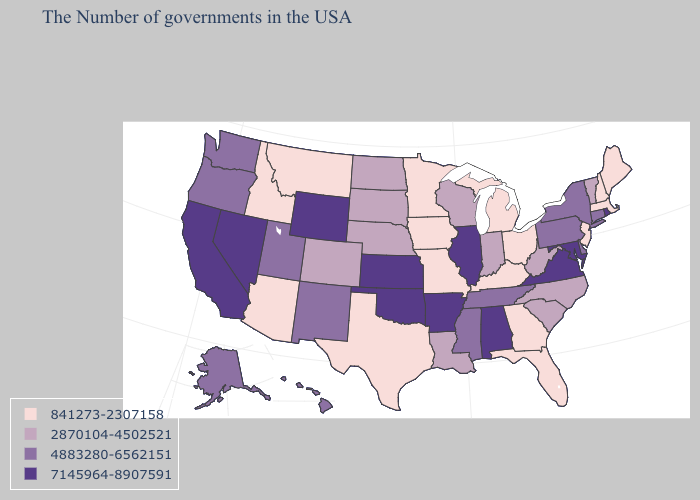Does South Dakota have a higher value than Wisconsin?
Keep it brief. No. Name the states that have a value in the range 7145964-8907591?
Give a very brief answer. Rhode Island, Maryland, Virginia, Alabama, Illinois, Arkansas, Kansas, Oklahoma, Wyoming, Nevada, California. What is the highest value in the West ?
Quick response, please. 7145964-8907591. Which states have the lowest value in the USA?
Short answer required. Maine, Massachusetts, New Hampshire, New Jersey, Ohio, Florida, Georgia, Michigan, Kentucky, Missouri, Minnesota, Iowa, Texas, Montana, Arizona, Idaho. Name the states that have a value in the range 4883280-6562151?
Keep it brief. Connecticut, New York, Delaware, Pennsylvania, Tennessee, Mississippi, New Mexico, Utah, Washington, Oregon, Alaska, Hawaii. What is the value of North Dakota?
Quick response, please. 2870104-4502521. What is the lowest value in the MidWest?
Be succinct. 841273-2307158. Name the states that have a value in the range 2870104-4502521?
Answer briefly. Vermont, North Carolina, South Carolina, West Virginia, Indiana, Wisconsin, Louisiana, Nebraska, South Dakota, North Dakota, Colorado. Name the states that have a value in the range 7145964-8907591?
Short answer required. Rhode Island, Maryland, Virginia, Alabama, Illinois, Arkansas, Kansas, Oklahoma, Wyoming, Nevada, California. Among the states that border Missouri , does Nebraska have the highest value?
Give a very brief answer. No. Name the states that have a value in the range 4883280-6562151?
Quick response, please. Connecticut, New York, Delaware, Pennsylvania, Tennessee, Mississippi, New Mexico, Utah, Washington, Oregon, Alaska, Hawaii. Among the states that border Colorado , does Arizona have the highest value?
Short answer required. No. Which states have the lowest value in the MidWest?
Keep it brief. Ohio, Michigan, Missouri, Minnesota, Iowa. Is the legend a continuous bar?
Give a very brief answer. No. What is the value of Maryland?
Be succinct. 7145964-8907591. 